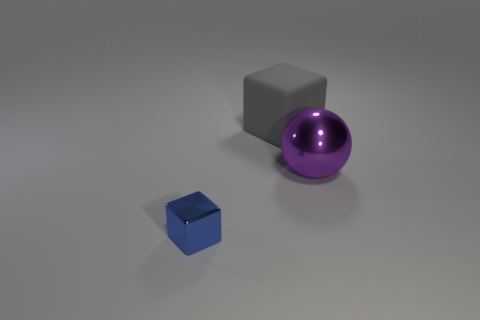Subtract all gray blocks. How many blocks are left? 1 Add 3 big rubber objects. How many objects exist? 6 Add 1 large gray blocks. How many large gray blocks are left? 2 Add 2 gray metallic cylinders. How many gray metallic cylinders exist? 2 Subtract 0 red blocks. How many objects are left? 3 Subtract all balls. How many objects are left? 2 Subtract all cyan blocks. Subtract all brown balls. How many blocks are left? 2 Subtract all brown balls. How many brown blocks are left? 0 Subtract all small red metal spheres. Subtract all blue things. How many objects are left? 2 